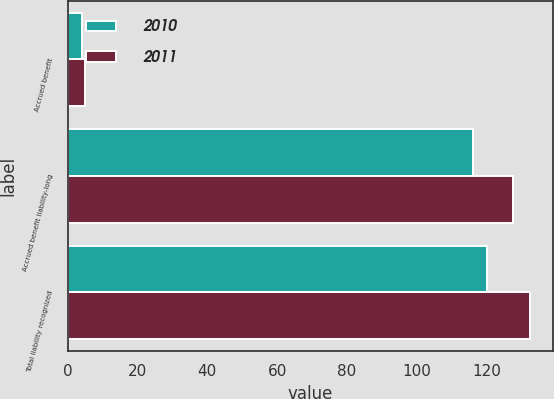Convert chart to OTSL. <chart><loc_0><loc_0><loc_500><loc_500><stacked_bar_chart><ecel><fcel>Accrued benefit<fcel>Accrued benefit liability-long<fcel>Total liability recognized<nl><fcel>2010<fcel>4.1<fcel>116.1<fcel>120.2<nl><fcel>2011<fcel>4.9<fcel>127.6<fcel>132.5<nl></chart> 